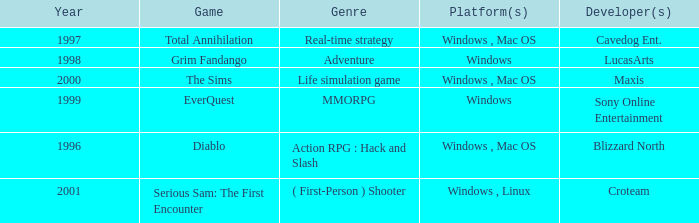What year is the Grim Fandango with a windows platform? 1998.0. 